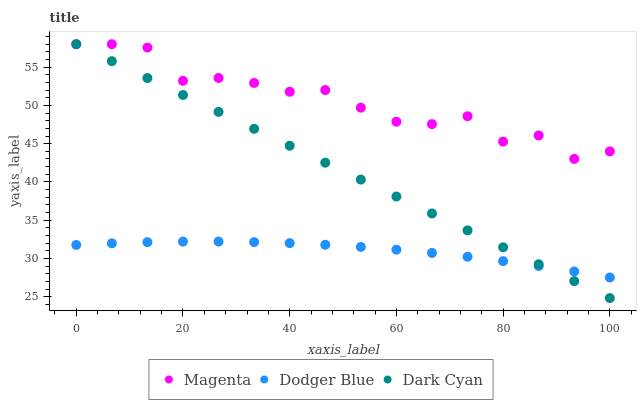Does Dodger Blue have the minimum area under the curve?
Answer yes or no. Yes. Does Magenta have the maximum area under the curve?
Answer yes or no. Yes. Does Magenta have the minimum area under the curve?
Answer yes or no. No. Does Dodger Blue have the maximum area under the curve?
Answer yes or no. No. Is Dark Cyan the smoothest?
Answer yes or no. Yes. Is Magenta the roughest?
Answer yes or no. Yes. Is Dodger Blue the smoothest?
Answer yes or no. No. Is Dodger Blue the roughest?
Answer yes or no. No. Does Dark Cyan have the lowest value?
Answer yes or no. Yes. Does Dodger Blue have the lowest value?
Answer yes or no. No. Does Magenta have the highest value?
Answer yes or no. Yes. Does Dodger Blue have the highest value?
Answer yes or no. No. Is Dodger Blue less than Magenta?
Answer yes or no. Yes. Is Magenta greater than Dodger Blue?
Answer yes or no. Yes. Does Dark Cyan intersect Magenta?
Answer yes or no. Yes. Is Dark Cyan less than Magenta?
Answer yes or no. No. Is Dark Cyan greater than Magenta?
Answer yes or no. No. Does Dodger Blue intersect Magenta?
Answer yes or no. No. 